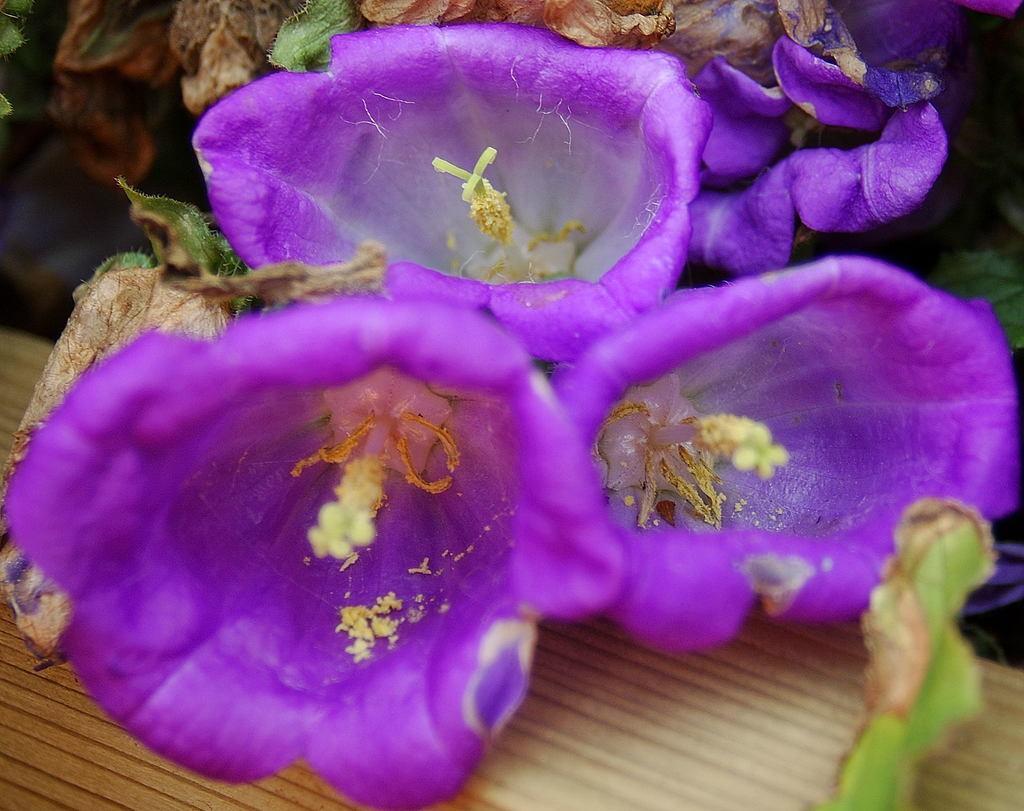Describe this image in one or two sentences. In the center of the image we can see one wooden object and flowers, which are in violet and white color. In the background we can see planets and a few other objects. 